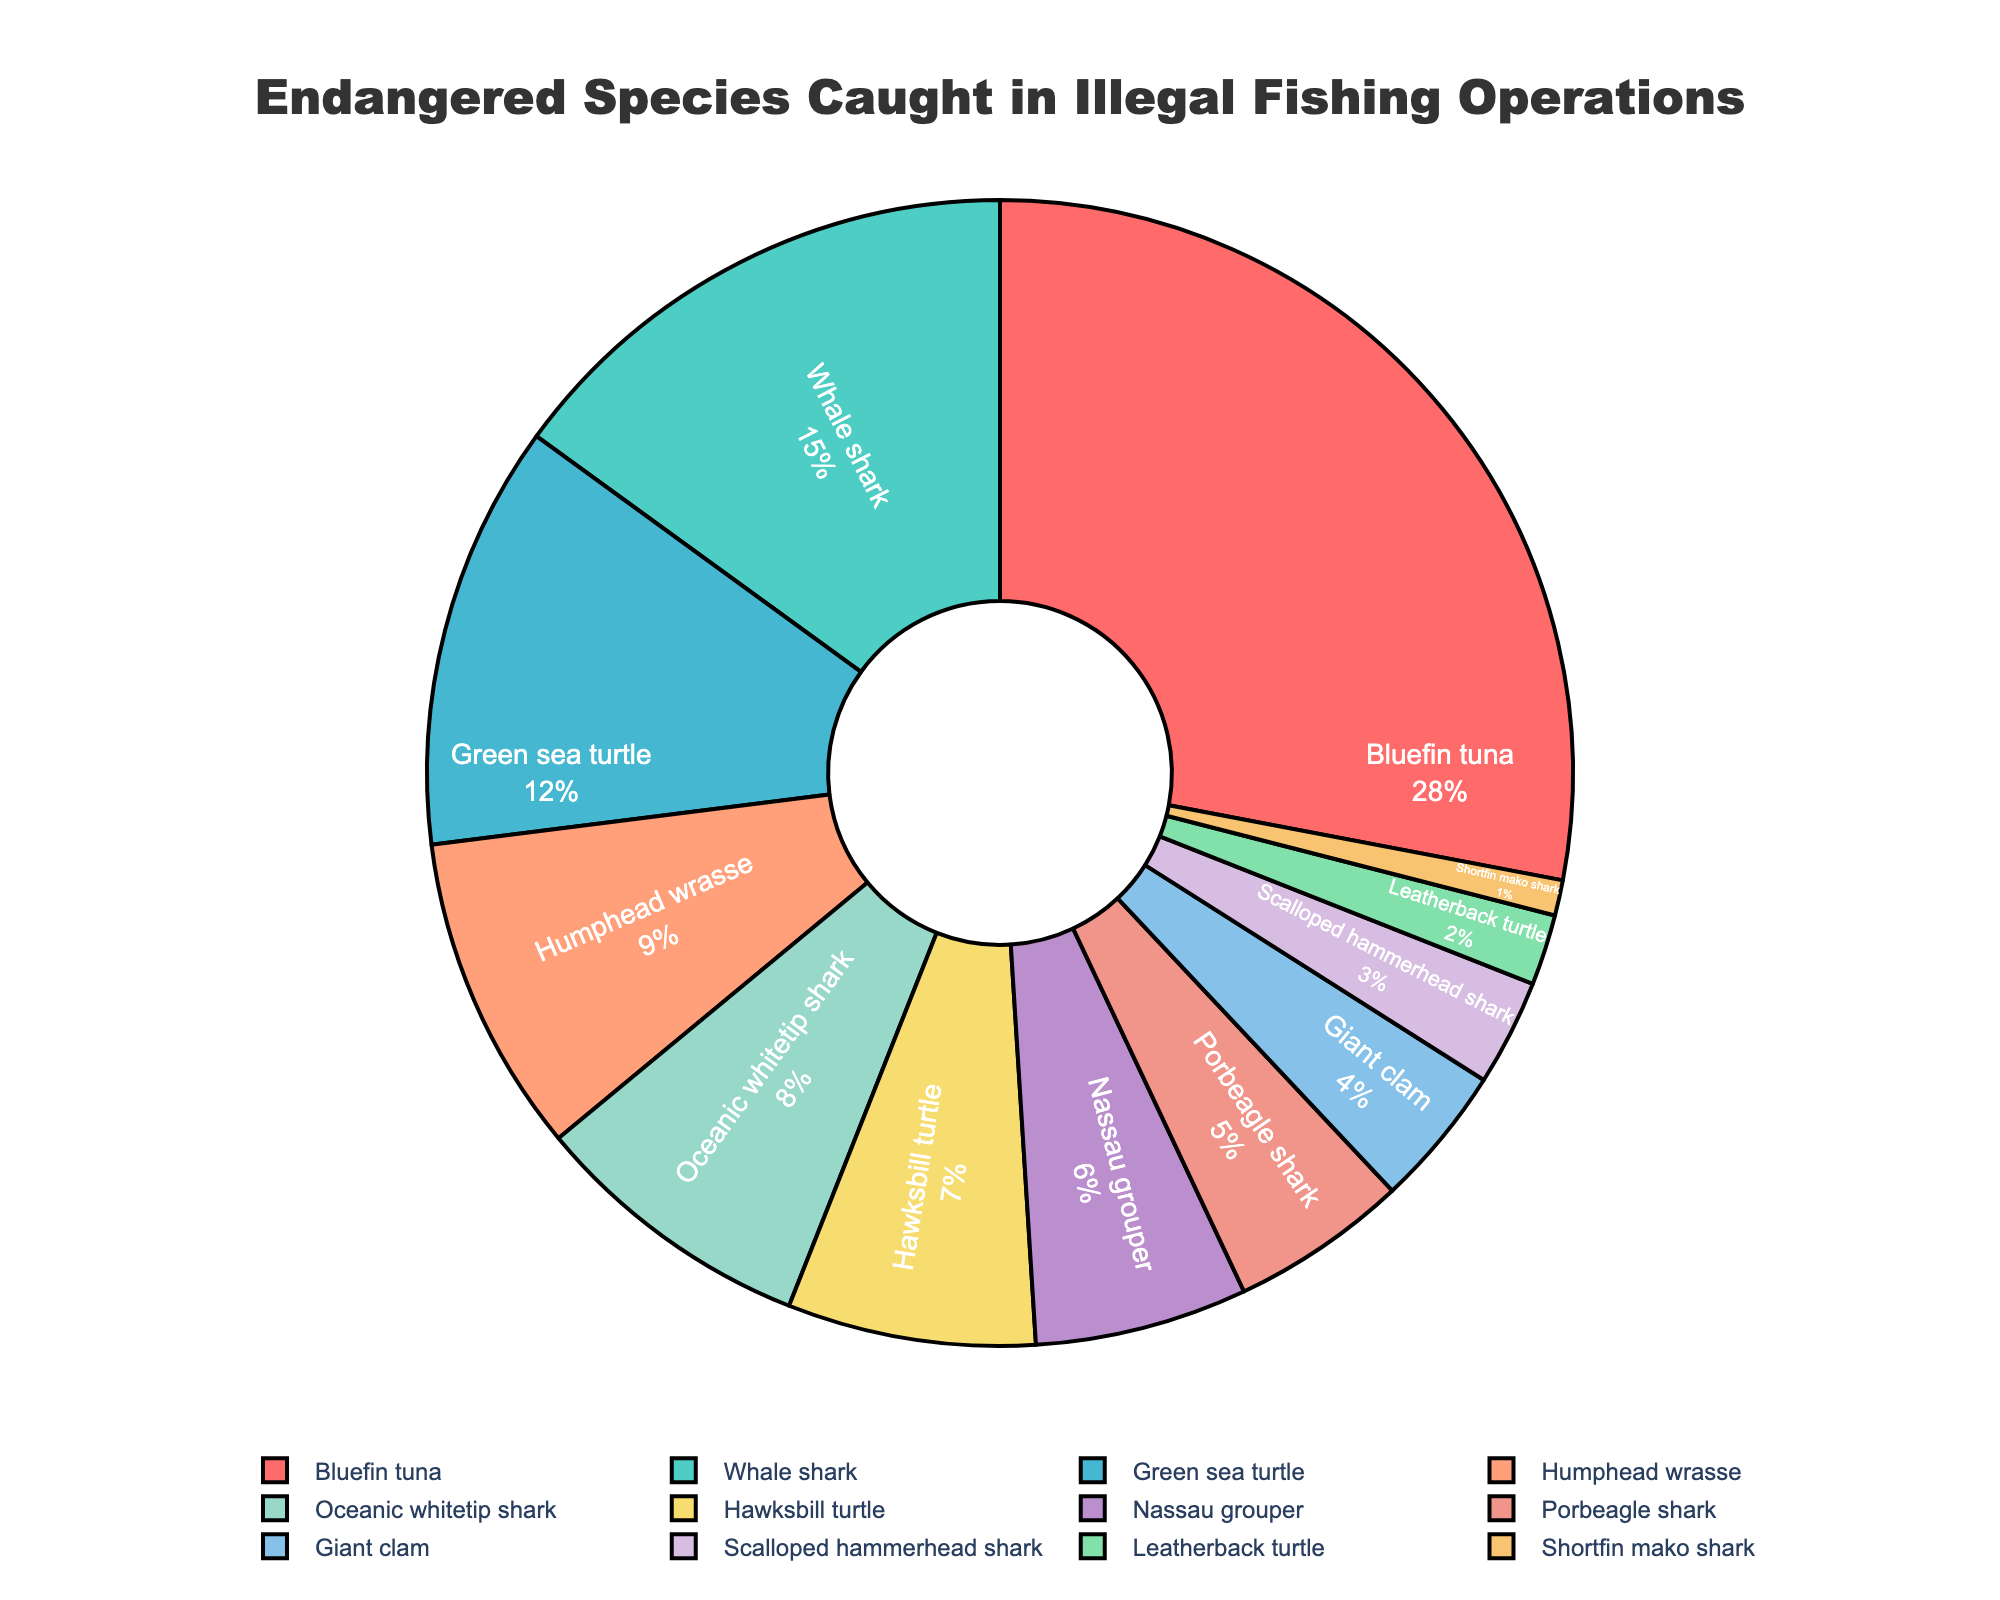What percentage of the catch is comprised of Bluefin tuna? Find the section labeled "Bluefin tuna" and note its corresponding percentage in the legend.
Answer: 28% Which species has the lowest percentage caught in illegal operations? Identify the smallest segment in the pie chart and check the corresponding label and percentage.
Answer: Shortfin mako shark What is the combined percentage of Green sea turtle and Hawksbill turtle? Locate the sections for Green sea turtle (12%) and Hawksbill turtle (7%) and sum their percentages: 12% + 7% = 19%.
Answer: 19% Between Whale shark and Oceanic whitetip shark, which has a higher percentage? Compare the segments labeled "Whale shark" (15%) and "Oceanic whitetip shark" (8%) and determine which has the higher value.
Answer: Whale shark How much greater is the percentage of Humphead wrasse compared to Scalloped hammerhead shark? Find the percentages for Humphead wrasse (9%) and Scalloped hammerhead shark (3%), then subtract the latter from the former: 9% - 3% = 6%.
Answer: 6% Which species are represented by the yellow and light green sections in the pie chart? Locate the yellow and light green sections visually and identify their corresponding labels.
Answer: Yellow: Humphead wrasse, Light green: Green sea turtle What is the combined percentage of Porbeagle shark, Giant clam, and Leatherback turtle? Add the percentages of Porbeagle shark (5%), Giant clam (4%), and Leatherback turtle (2%): 5% + 4% + 2% = 11%.
Answer: 11% Of the species listed, which comprise under 5% of the illegal catch? Identify the sections with percentages less than 5%: Porbeagle shark (5%), Giant clam (4%), Scalloped hammerhead shark (3%), Leatherback turtle (2%), and Shortfin mako shark (1%). Exclude the 5% and only consider those below it.
Answer: Giant clam, Scalloped hammerhead shark, Leatherback turtle, Shortfin mako shark 